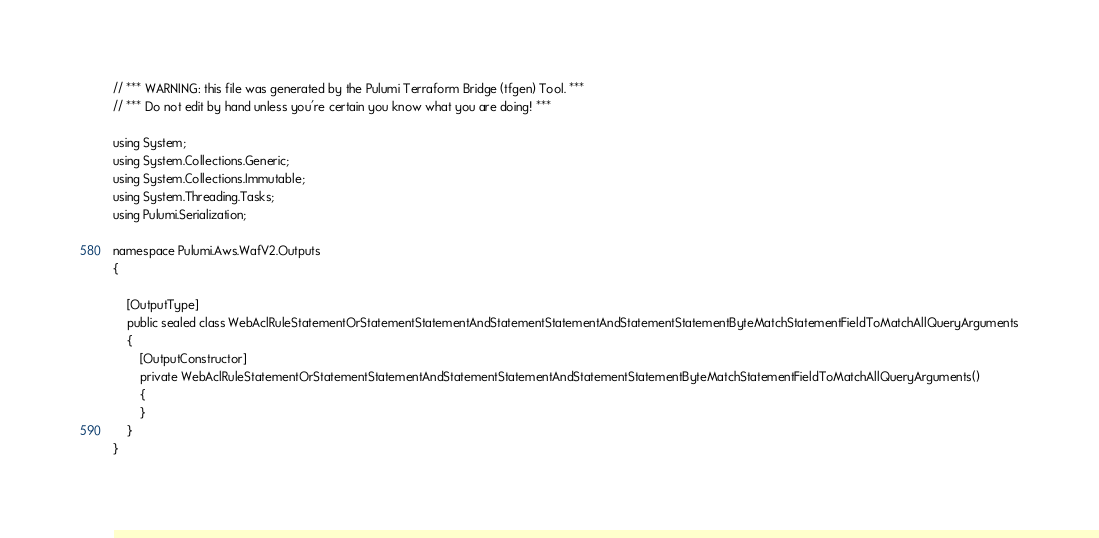Convert code to text. <code><loc_0><loc_0><loc_500><loc_500><_C#_>// *** WARNING: this file was generated by the Pulumi Terraform Bridge (tfgen) Tool. ***
// *** Do not edit by hand unless you're certain you know what you are doing! ***

using System;
using System.Collections.Generic;
using System.Collections.Immutable;
using System.Threading.Tasks;
using Pulumi.Serialization;

namespace Pulumi.Aws.WafV2.Outputs
{

    [OutputType]
    public sealed class WebAclRuleStatementOrStatementStatementAndStatementStatementAndStatementStatementByteMatchStatementFieldToMatchAllQueryArguments
    {
        [OutputConstructor]
        private WebAclRuleStatementOrStatementStatementAndStatementStatementAndStatementStatementByteMatchStatementFieldToMatchAllQueryArguments()
        {
        }
    }
}
</code> 